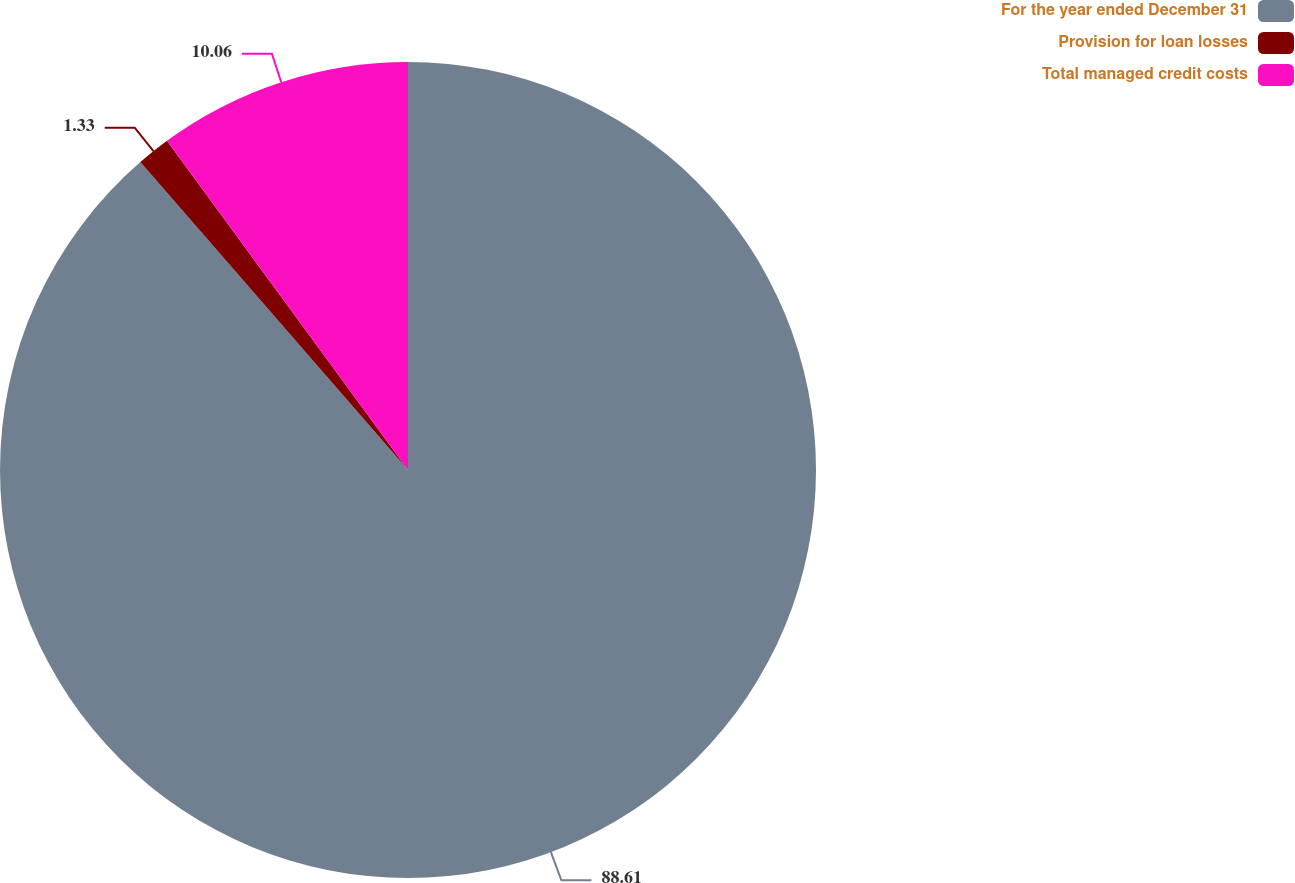<chart> <loc_0><loc_0><loc_500><loc_500><pie_chart><fcel>For the year ended December 31<fcel>Provision for loan losses<fcel>Total managed credit costs<nl><fcel>88.62%<fcel>1.33%<fcel>10.06%<nl></chart> 